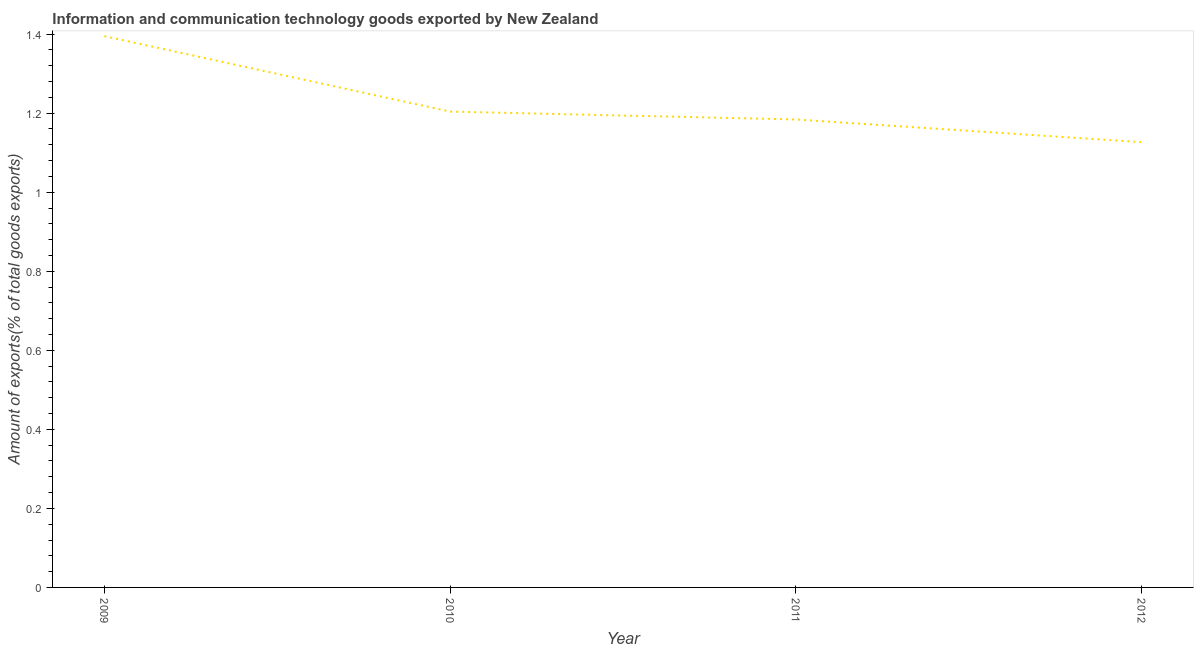What is the amount of ict goods exports in 2011?
Your answer should be compact. 1.18. Across all years, what is the maximum amount of ict goods exports?
Provide a succinct answer. 1.39. Across all years, what is the minimum amount of ict goods exports?
Ensure brevity in your answer.  1.13. In which year was the amount of ict goods exports maximum?
Your answer should be very brief. 2009. What is the sum of the amount of ict goods exports?
Offer a terse response. 4.91. What is the difference between the amount of ict goods exports in 2010 and 2012?
Make the answer very short. 0.08. What is the average amount of ict goods exports per year?
Offer a very short reply. 1.23. What is the median amount of ict goods exports?
Give a very brief answer. 1.19. In how many years, is the amount of ict goods exports greater than 1 %?
Make the answer very short. 4. What is the ratio of the amount of ict goods exports in 2009 to that in 2011?
Your answer should be compact. 1.18. Is the amount of ict goods exports in 2010 less than that in 2011?
Ensure brevity in your answer.  No. Is the difference between the amount of ict goods exports in 2010 and 2011 greater than the difference between any two years?
Provide a short and direct response. No. What is the difference between the highest and the second highest amount of ict goods exports?
Your answer should be compact. 0.19. Is the sum of the amount of ict goods exports in 2009 and 2011 greater than the maximum amount of ict goods exports across all years?
Make the answer very short. Yes. What is the difference between the highest and the lowest amount of ict goods exports?
Ensure brevity in your answer.  0.27. In how many years, is the amount of ict goods exports greater than the average amount of ict goods exports taken over all years?
Provide a short and direct response. 1. How many lines are there?
Keep it short and to the point. 1. How many years are there in the graph?
Make the answer very short. 4. What is the difference between two consecutive major ticks on the Y-axis?
Provide a succinct answer. 0.2. Are the values on the major ticks of Y-axis written in scientific E-notation?
Make the answer very short. No. Does the graph contain any zero values?
Provide a succinct answer. No. What is the title of the graph?
Your answer should be very brief. Information and communication technology goods exported by New Zealand. What is the label or title of the X-axis?
Your answer should be compact. Year. What is the label or title of the Y-axis?
Provide a succinct answer. Amount of exports(% of total goods exports). What is the Amount of exports(% of total goods exports) in 2009?
Your response must be concise. 1.39. What is the Amount of exports(% of total goods exports) of 2010?
Provide a short and direct response. 1.2. What is the Amount of exports(% of total goods exports) of 2011?
Your answer should be compact. 1.18. What is the Amount of exports(% of total goods exports) of 2012?
Keep it short and to the point. 1.13. What is the difference between the Amount of exports(% of total goods exports) in 2009 and 2010?
Provide a succinct answer. 0.19. What is the difference between the Amount of exports(% of total goods exports) in 2009 and 2011?
Offer a terse response. 0.21. What is the difference between the Amount of exports(% of total goods exports) in 2009 and 2012?
Make the answer very short. 0.27. What is the difference between the Amount of exports(% of total goods exports) in 2010 and 2011?
Make the answer very short. 0.02. What is the difference between the Amount of exports(% of total goods exports) in 2010 and 2012?
Provide a succinct answer. 0.08. What is the difference between the Amount of exports(% of total goods exports) in 2011 and 2012?
Make the answer very short. 0.06. What is the ratio of the Amount of exports(% of total goods exports) in 2009 to that in 2010?
Offer a very short reply. 1.16. What is the ratio of the Amount of exports(% of total goods exports) in 2009 to that in 2011?
Your answer should be compact. 1.18. What is the ratio of the Amount of exports(% of total goods exports) in 2009 to that in 2012?
Keep it short and to the point. 1.24. What is the ratio of the Amount of exports(% of total goods exports) in 2010 to that in 2011?
Keep it short and to the point. 1.02. What is the ratio of the Amount of exports(% of total goods exports) in 2010 to that in 2012?
Offer a very short reply. 1.07. What is the ratio of the Amount of exports(% of total goods exports) in 2011 to that in 2012?
Your answer should be compact. 1.05. 